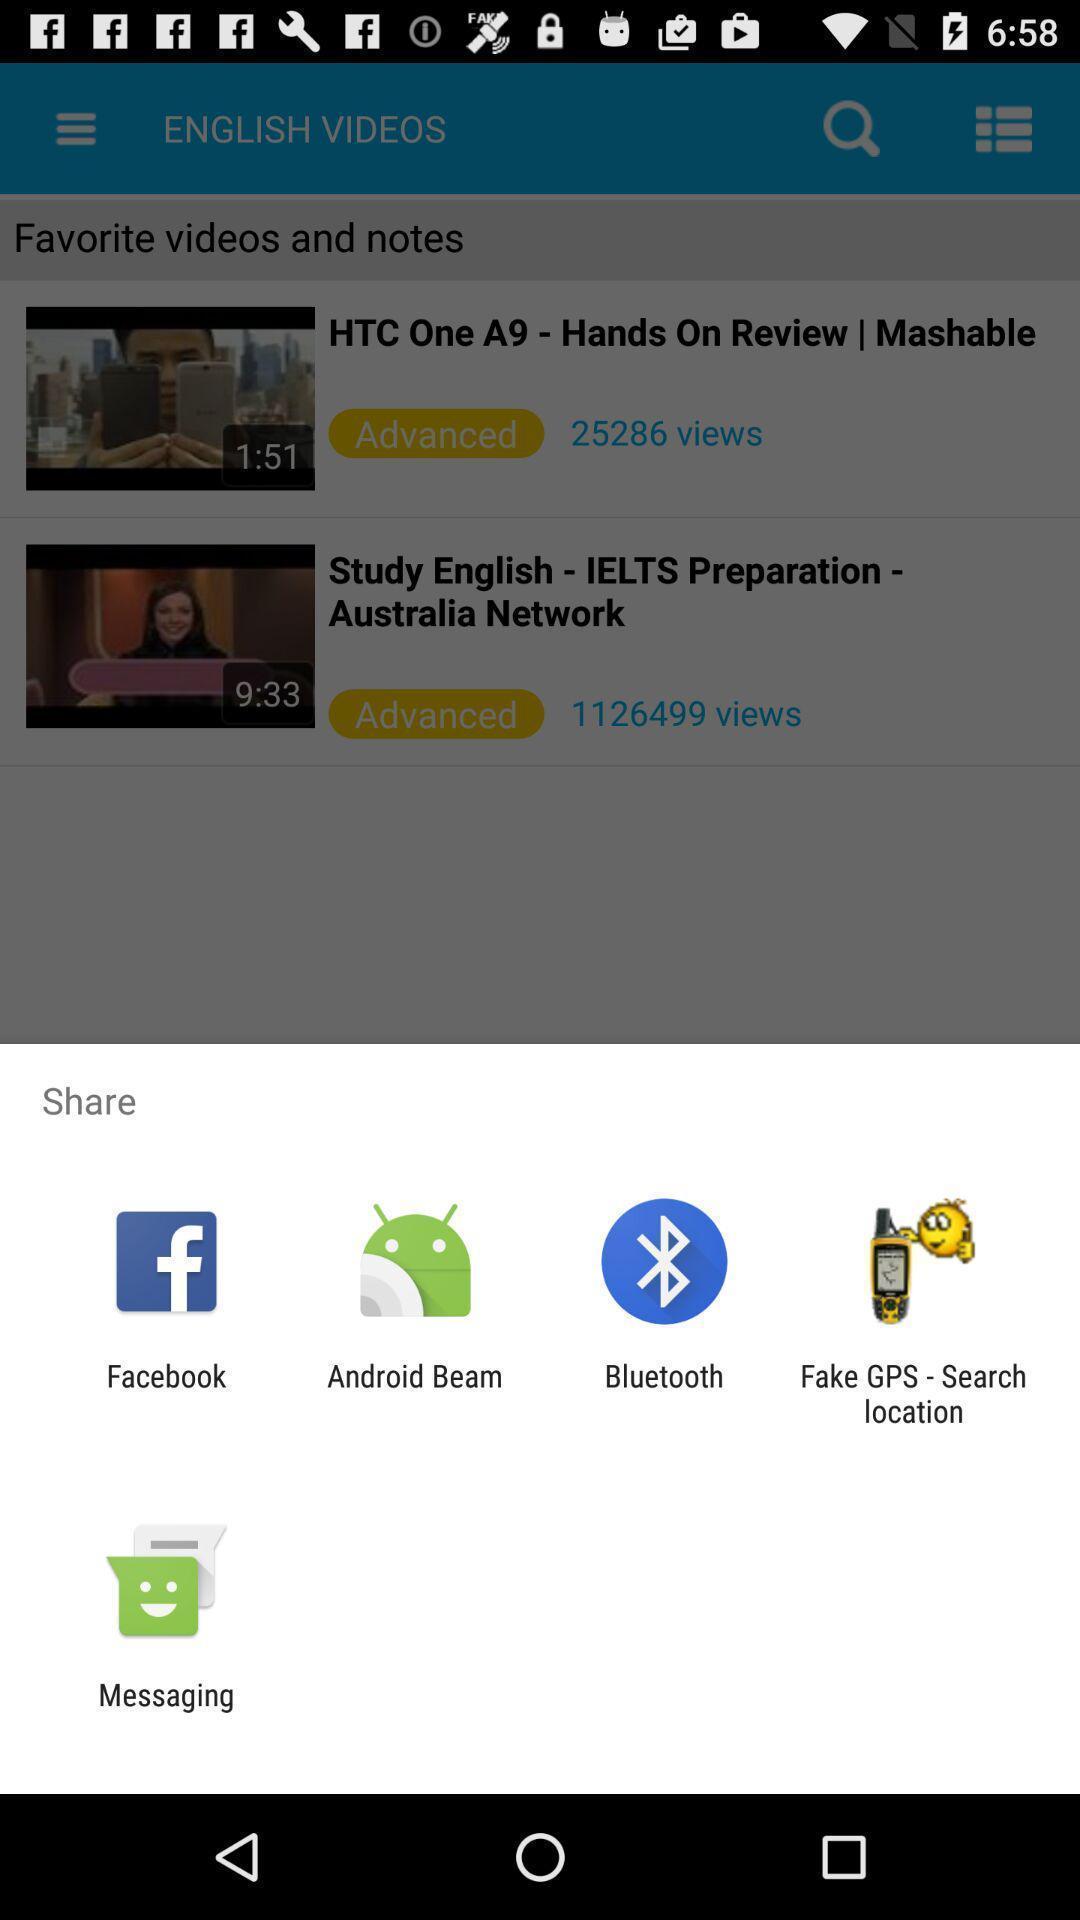Summarize the main components in this picture. Share options page of a learning app. 